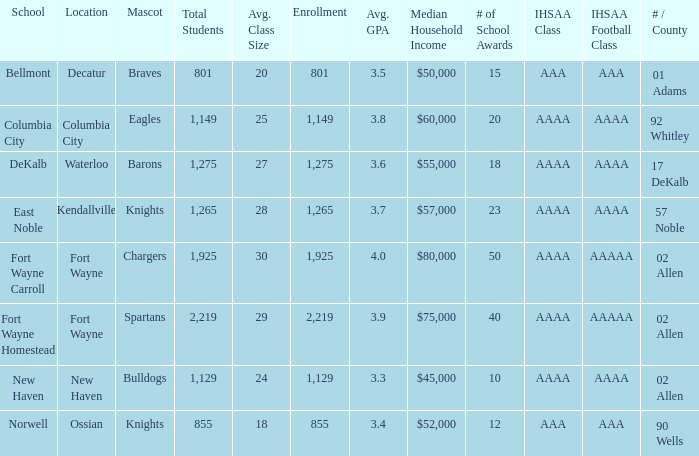What's the enrollment for Kendallville? 1265.0. 